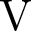Convert formula to latex. <formula><loc_0><loc_0><loc_500><loc_500>V</formula> 